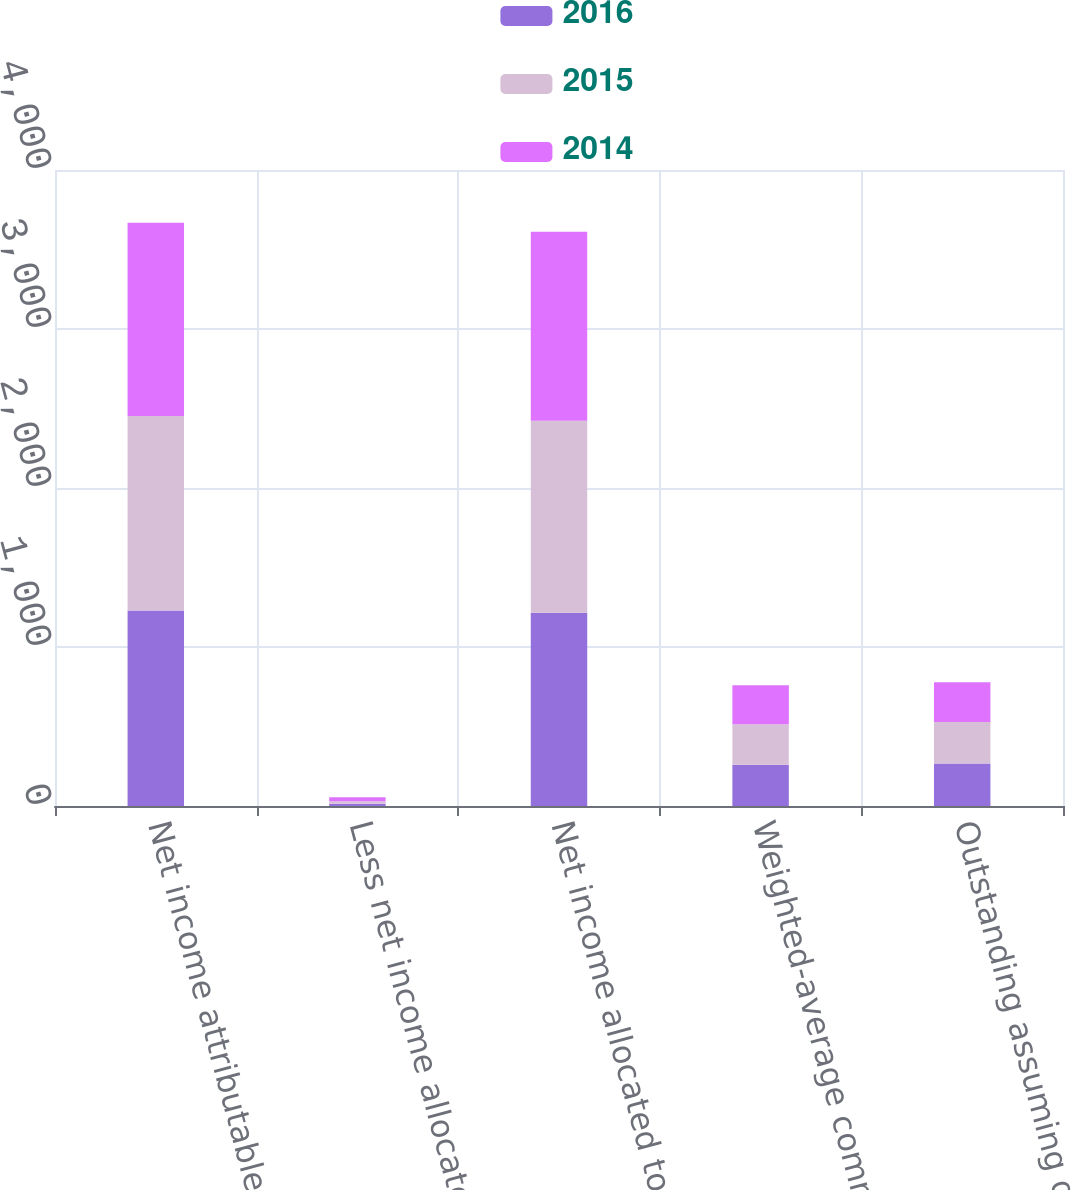Convert chart to OTSL. <chart><loc_0><loc_0><loc_500><loc_500><stacked_bar_chart><ecel><fcel>Net income attributable to T<fcel>Less net income allocated to<fcel>Net income allocated to common<fcel>Weighted-average common shares<fcel>Outstanding assuming dilution<nl><fcel>2016<fcel>1229.6<fcel>14.2<fcel>1215.4<fcel>259.6<fcel>267.4<nl><fcel>2015<fcel>1223<fcel>16.1<fcel>1206.9<fcel>254.6<fcel>260.9<nl><fcel>2014<fcel>1215<fcel>25.5<fcel>1189.5<fcel>245.5<fcel>250.3<nl></chart> 